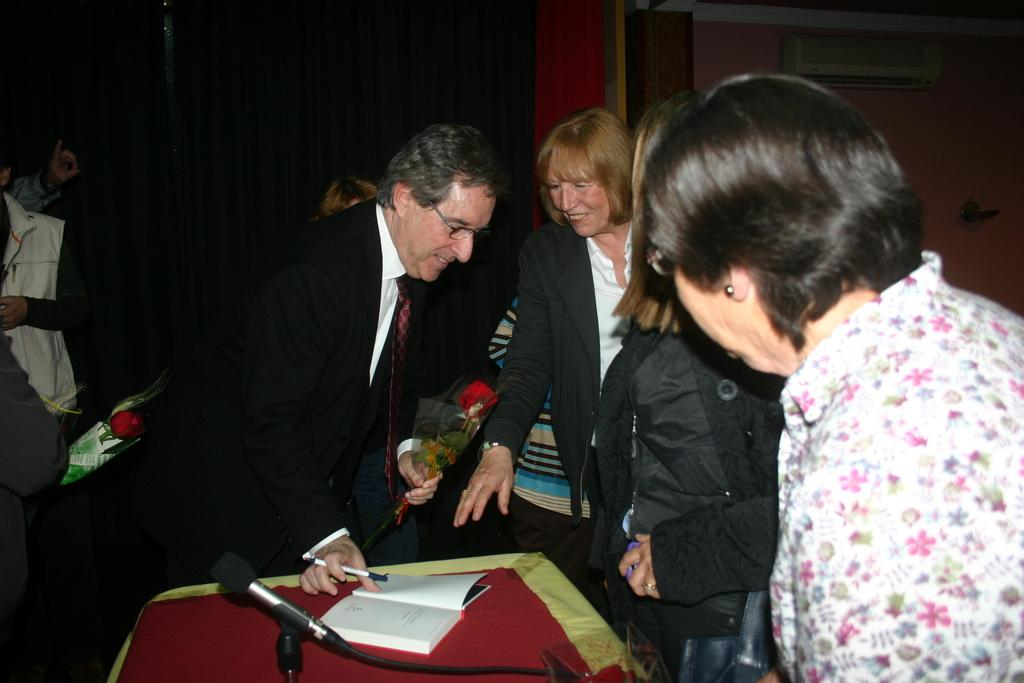Who or what is present in the image? There are people in the image. What object can be seen in the image that is typically used for amplifying sound? There is a mic in the image. What piece of furniture is visible in the image? There is a table in the image. What item is placed on the table in the image? There is a book on the table. What type of minister is sitting on the cushion in the image? There is no minister or cushion present in the image. How many fowl are visible in the image? There are no fowl present in the image. 